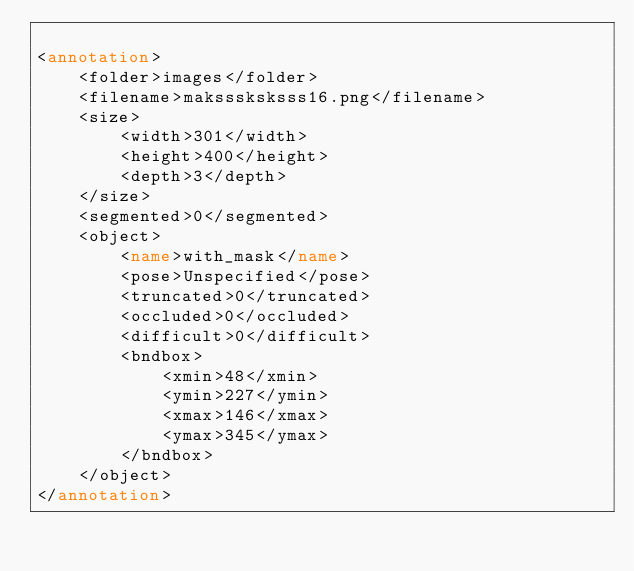<code> <loc_0><loc_0><loc_500><loc_500><_XML_>
<annotation>
    <folder>images</folder>
    <filename>maksssksksss16.png</filename>
    <size>
        <width>301</width>
        <height>400</height>
        <depth>3</depth>
    </size>
    <segmented>0</segmented>
    <object>
        <name>with_mask</name>
        <pose>Unspecified</pose>
        <truncated>0</truncated>
        <occluded>0</occluded>
        <difficult>0</difficult>
        <bndbox>
            <xmin>48</xmin>
            <ymin>227</ymin>
            <xmax>146</xmax>
            <ymax>345</ymax>
        </bndbox>
    </object>
</annotation></code> 